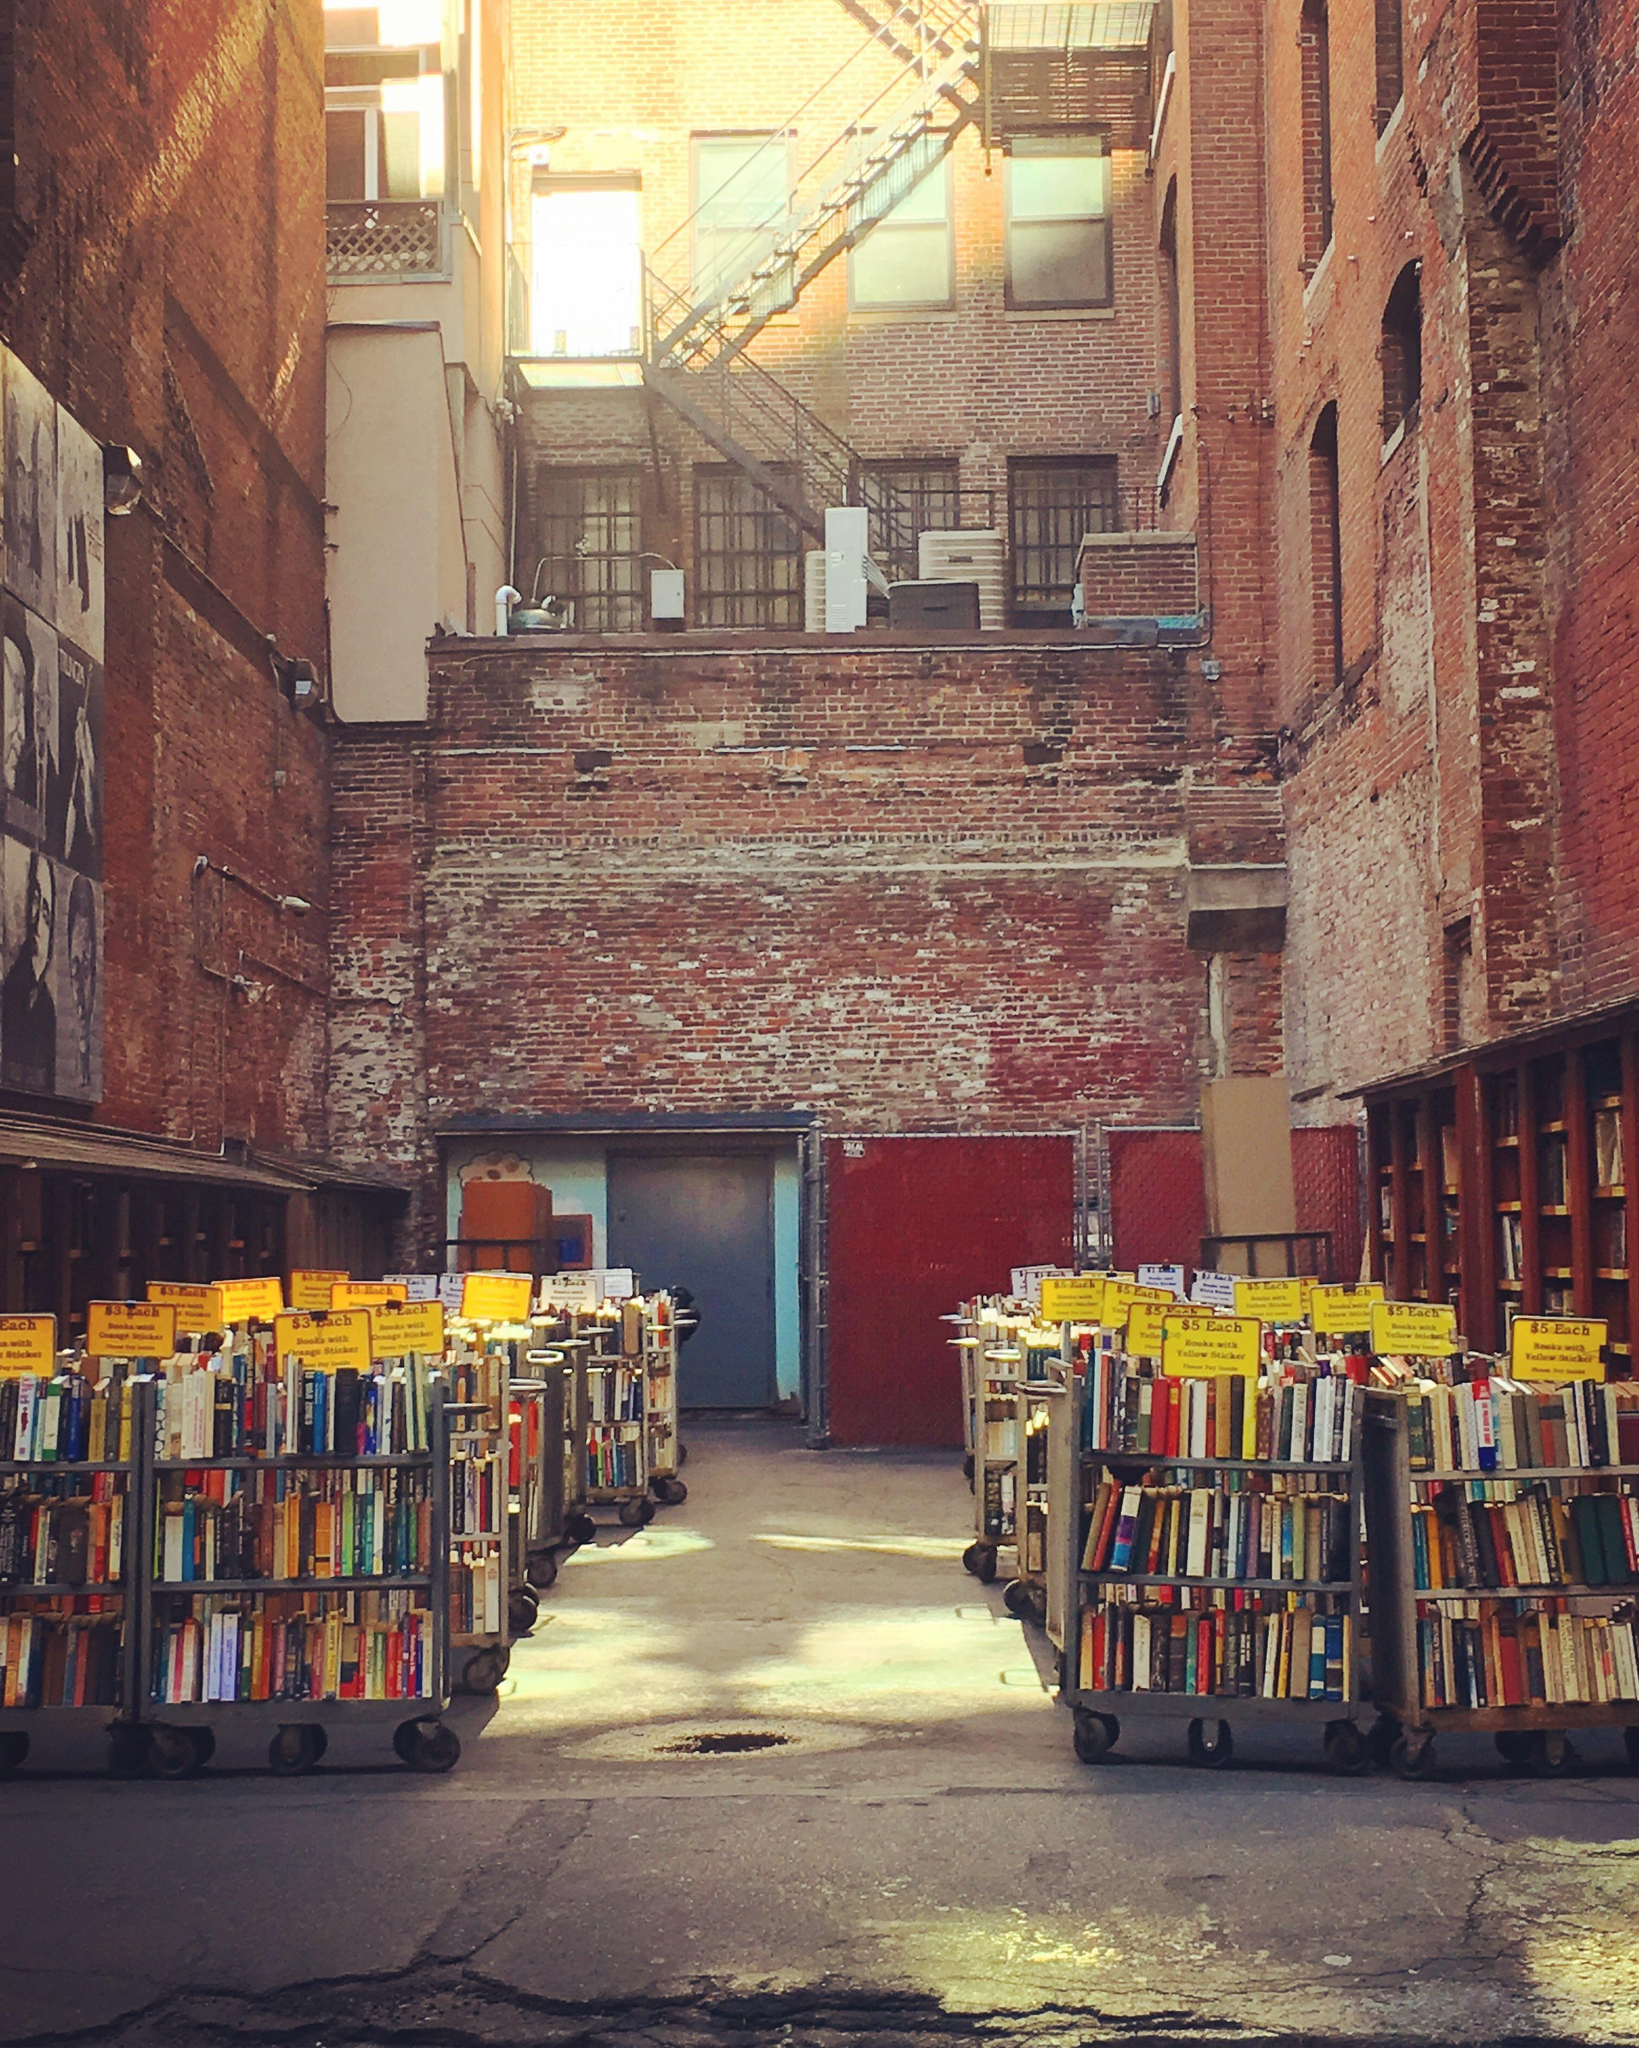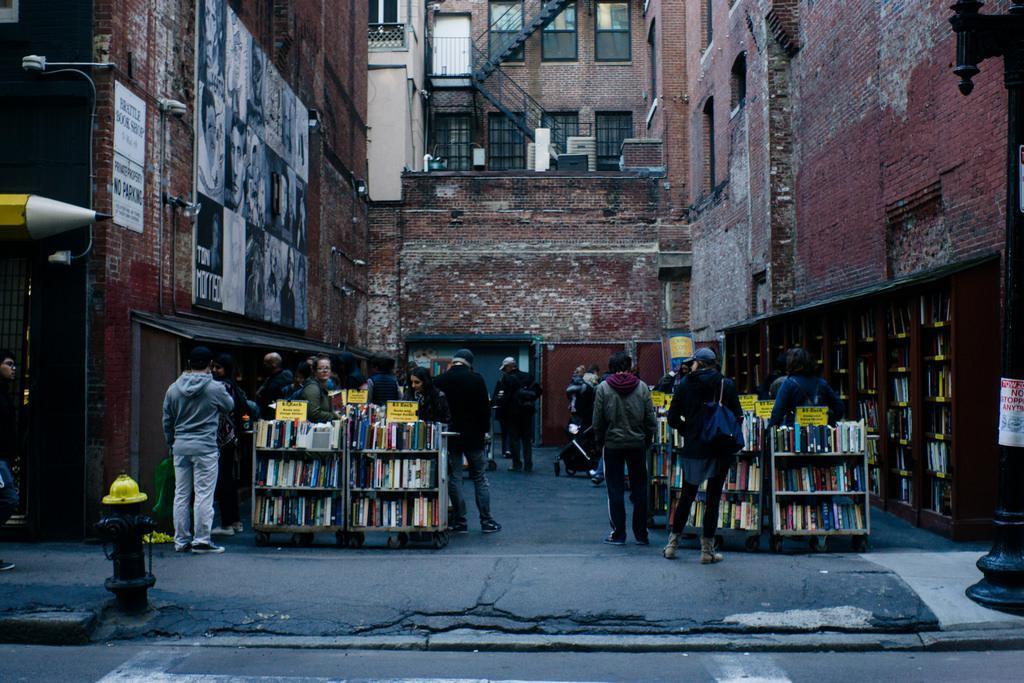The first image is the image on the left, the second image is the image on the right. Analyze the images presented: Is the assertion "People are looking at books in an alley in the image on the right." valid? Answer yes or no. Yes. 